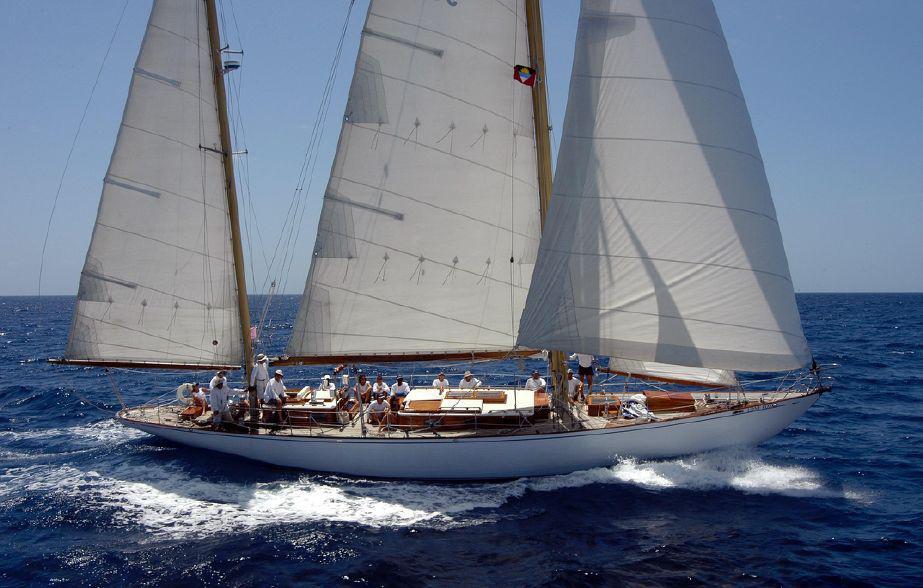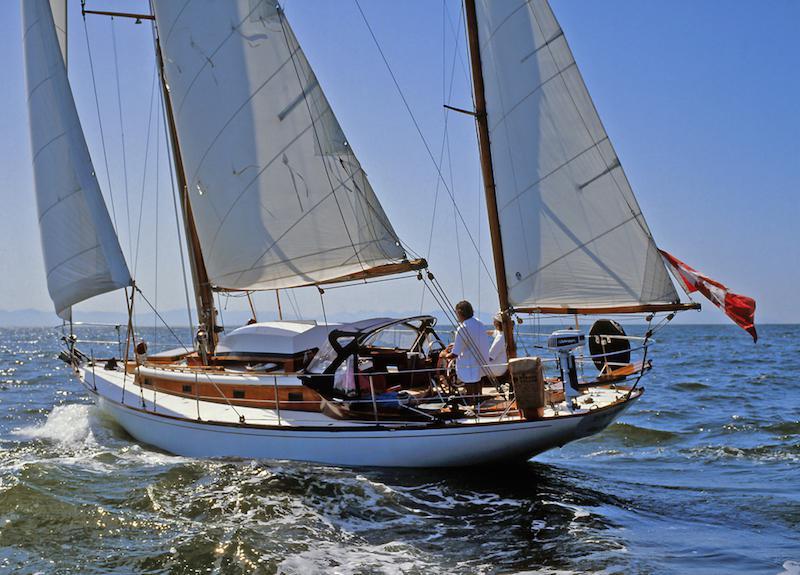The first image is the image on the left, the second image is the image on the right. Evaluate the accuracy of this statement regarding the images: "One of the images features a sailboat with its sails furled". Is it true? Answer yes or no. No. The first image is the image on the left, the second image is the image on the right. Evaluate the accuracy of this statement regarding the images: "One of the boats has all its sails furled and is aimed toward the right.". Is it true? Answer yes or no. No. 